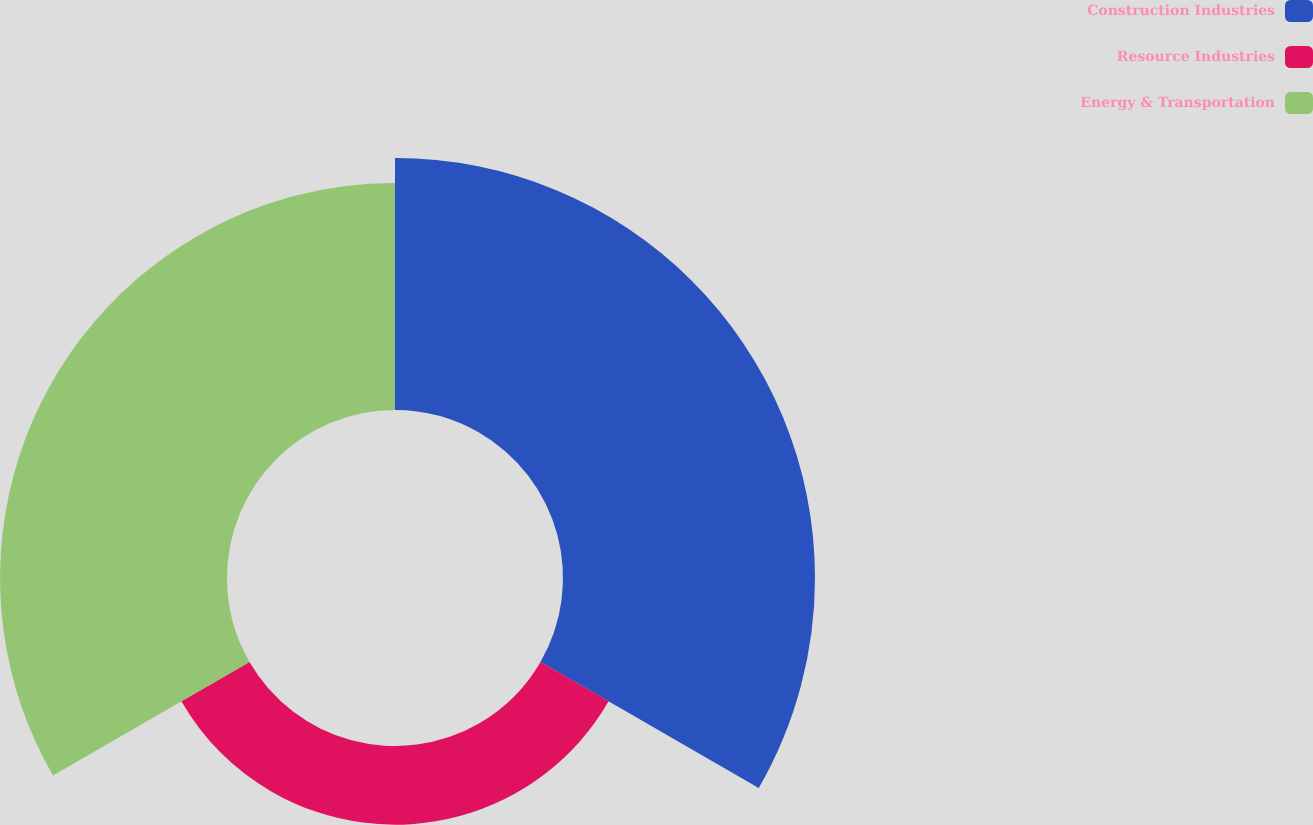Convert chart to OTSL. <chart><loc_0><loc_0><loc_500><loc_500><pie_chart><fcel>Construction Industries<fcel>Resource Industries<fcel>Energy & Transportation<nl><fcel>45.19%<fcel>14.11%<fcel>40.7%<nl></chart> 